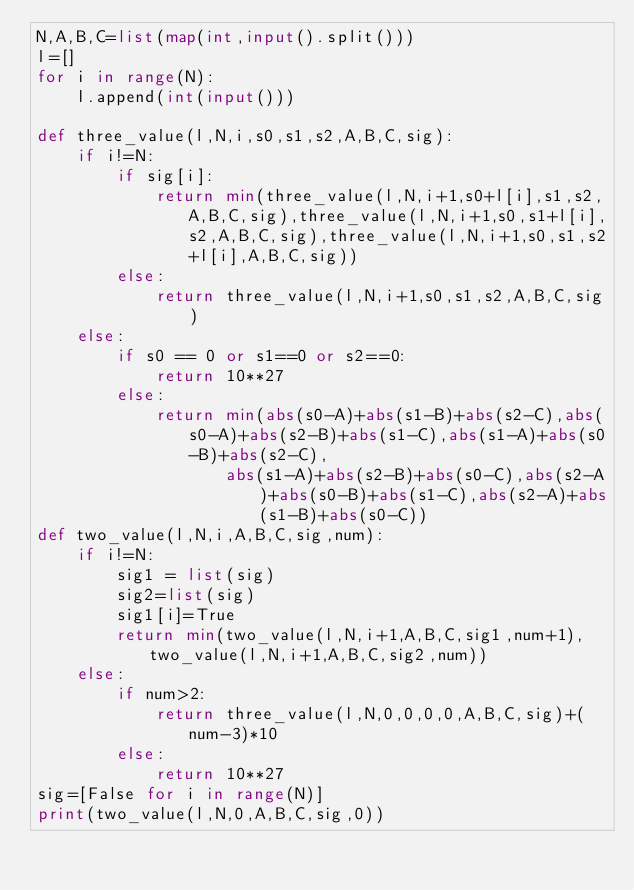<code> <loc_0><loc_0><loc_500><loc_500><_Python_>N,A,B,C=list(map(int,input().split()))
l=[]
for i in range(N):
    l.append(int(input()))
    
def three_value(l,N,i,s0,s1,s2,A,B,C,sig):
    if i!=N:
        if sig[i]:
            return min(three_value(l,N,i+1,s0+l[i],s1,s2,A,B,C,sig),three_value(l,N,i+1,s0,s1+l[i],s2,A,B,C,sig),three_value(l,N,i+1,s0,s1,s2+l[i],A,B,C,sig))
        else:
            return three_value(l,N,i+1,s0,s1,s2,A,B,C,sig)
    else:
        if s0 == 0 or s1==0 or s2==0:
            return 10**27
        else:
            return min(abs(s0-A)+abs(s1-B)+abs(s2-C),abs(s0-A)+abs(s2-B)+abs(s1-C),abs(s1-A)+abs(s0-B)+abs(s2-C),
                   abs(s1-A)+abs(s2-B)+abs(s0-C),abs(s2-A)+abs(s0-B)+abs(s1-C),abs(s2-A)+abs(s1-B)+abs(s0-C))
def two_value(l,N,i,A,B,C,sig,num):
    if i!=N:
        sig1 = list(sig)
        sig2=list(sig)
        sig1[i]=True
        return min(two_value(l,N,i+1,A,B,C,sig1,num+1),two_value(l,N,i+1,A,B,C,sig2,num))
    else:
        if num>2:
            return three_value(l,N,0,0,0,0,A,B,C,sig)+(num-3)*10
        else:
            return 10**27
sig=[False for i in range(N)]
print(two_value(l,N,0,A,B,C,sig,0))
        </code> 